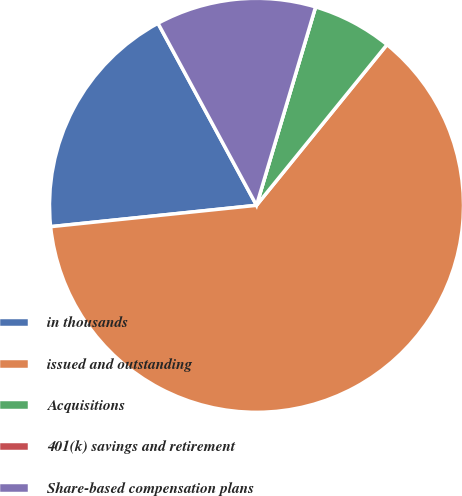Convert chart. <chart><loc_0><loc_0><loc_500><loc_500><pie_chart><fcel>in thousands<fcel>issued and outstanding<fcel>Acquisitions<fcel>401(k) savings and retirement<fcel>Share-based compensation plans<nl><fcel>18.75%<fcel>62.5%<fcel>6.25%<fcel>0.0%<fcel>12.5%<nl></chart> 